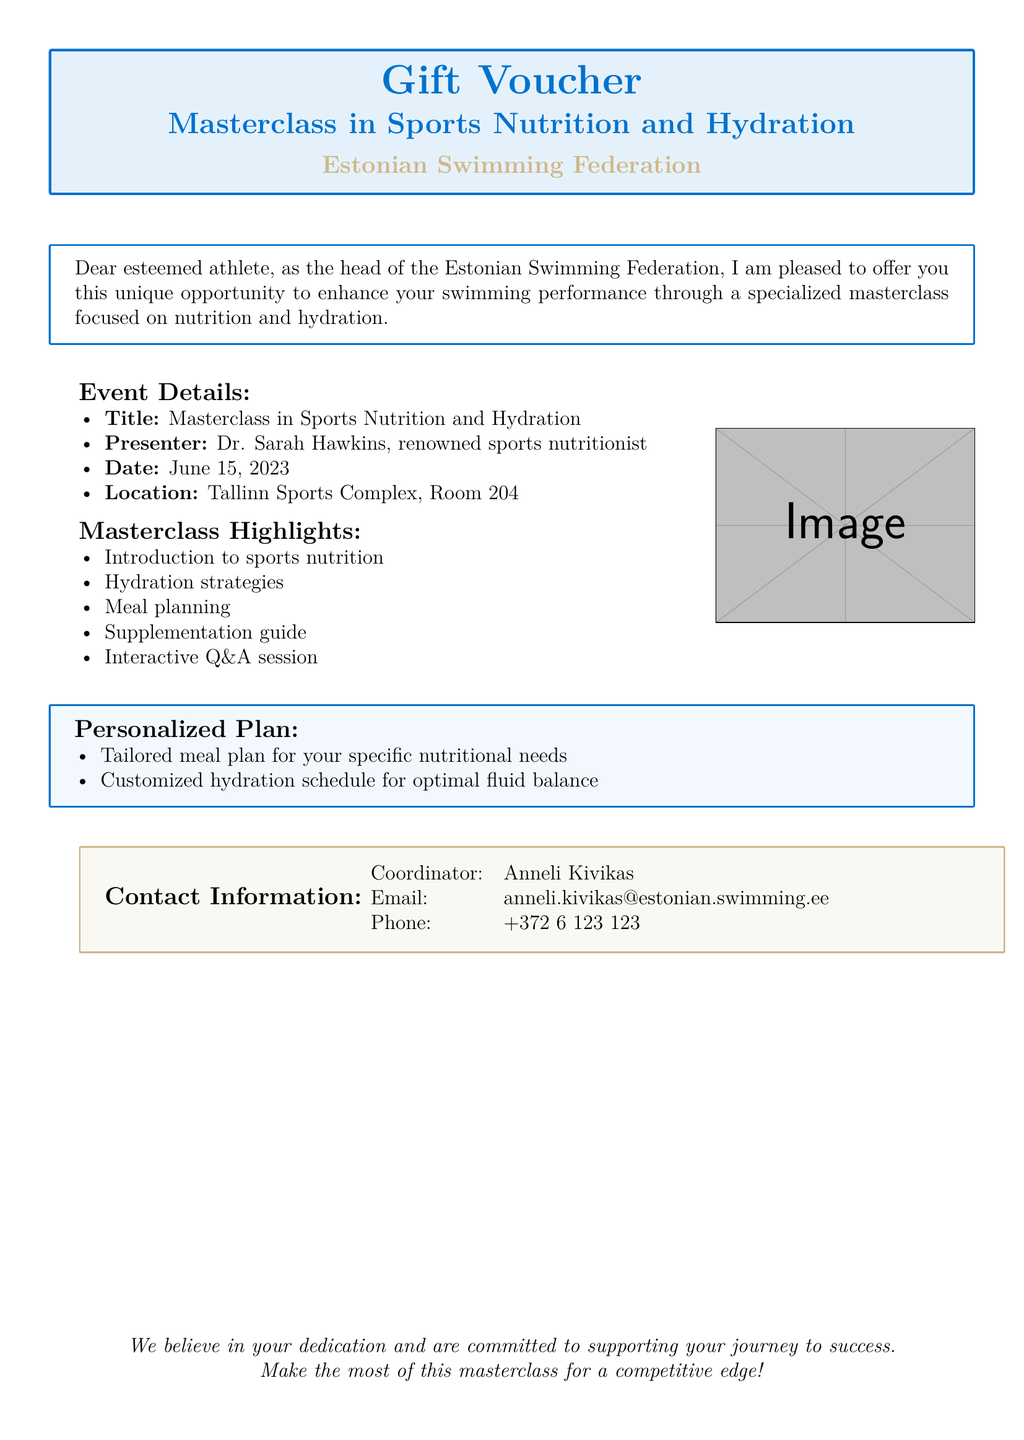What is the title of the masterclass? The title is explicitly mentioned in the document as the main focus of the voucher.
Answer: Masterclass in Sports Nutrition and Hydration Who is the presenter of the masterclass? The presenter's name is provided as part of the event details in the document.
Answer: Dr. Sarah Hawkins When is the masterclass scheduled? The date is clearly stated in the document.
Answer: June 15, 2023 Where will the masterclass take place? The location is specified in the event details of the document.
Answer: Tallinn Sports Complex, Room 204 What type of personalized plan is included in the voucher? The document outlines the specific components of the personalized plan offered.
Answer: Tailored meal plan and customized hydration schedule What will participants learn about during the masterclass? The highlights list provides an overview of the topics covered in the masterclass.
Answer: Sports nutrition and hydration strategies Who can be contacted for more information? The contact information section lists the coordinator for inquiries.
Answer: Anneli Kivikas What is the email address provided for contact? The document includes a specific email for contacting the coordinator.
Answer: anneli.kivikas@estonian.swimming.ee 